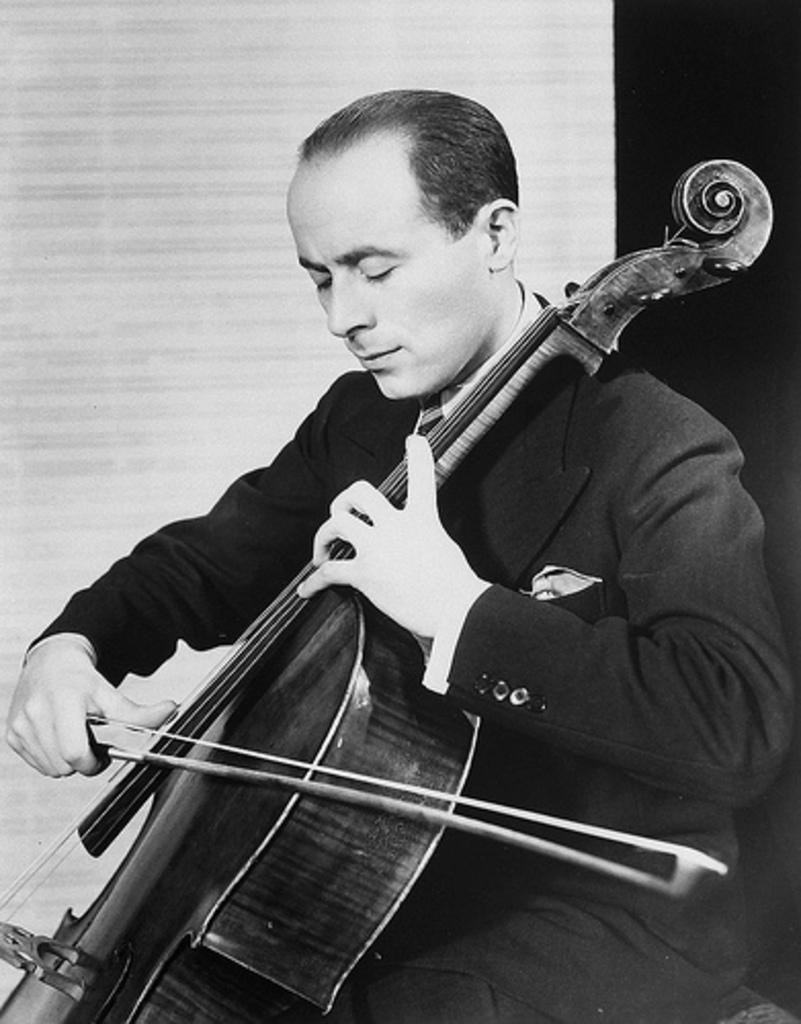Please provide a concise description of this image. Black and white picture. This man is sitting on a chair and playing violin. 